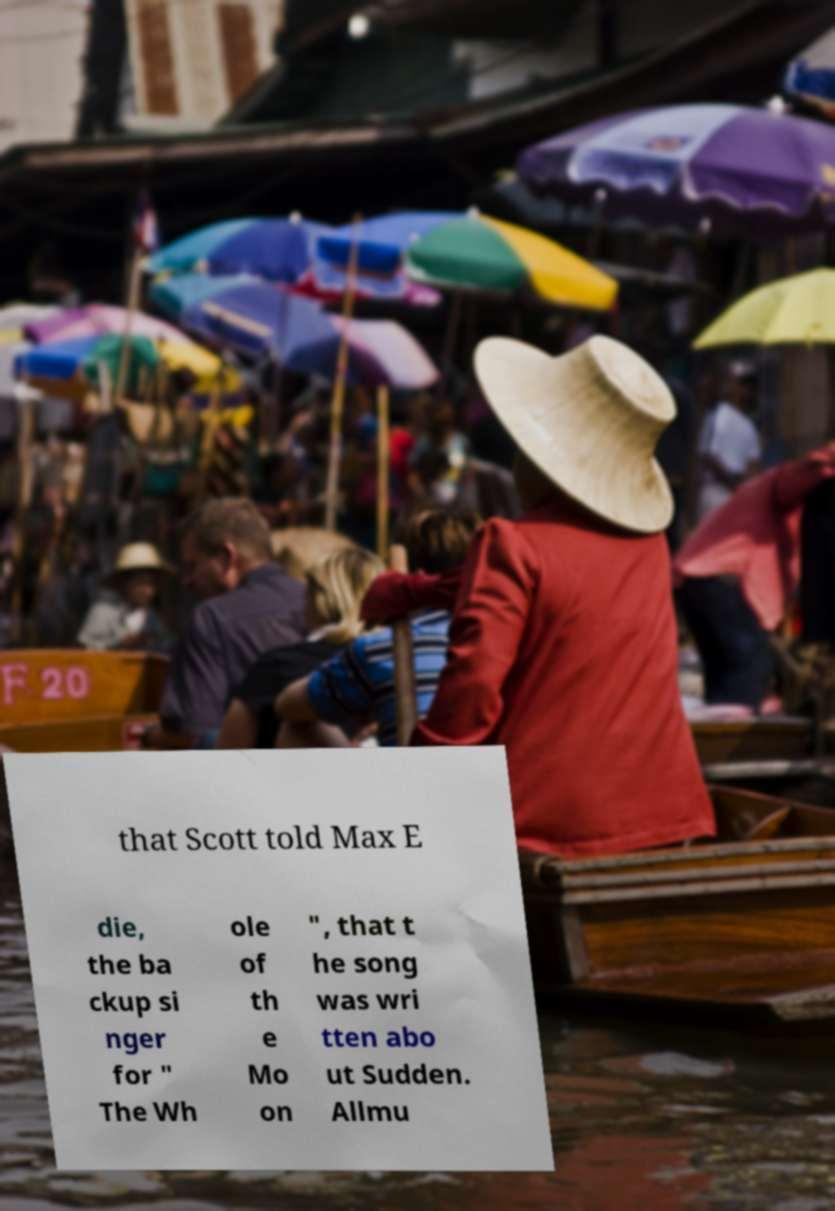For documentation purposes, I need the text within this image transcribed. Could you provide that? that Scott told Max E die, the ba ckup si nger for " The Wh ole of th e Mo on ", that t he song was wri tten abo ut Sudden. Allmu 